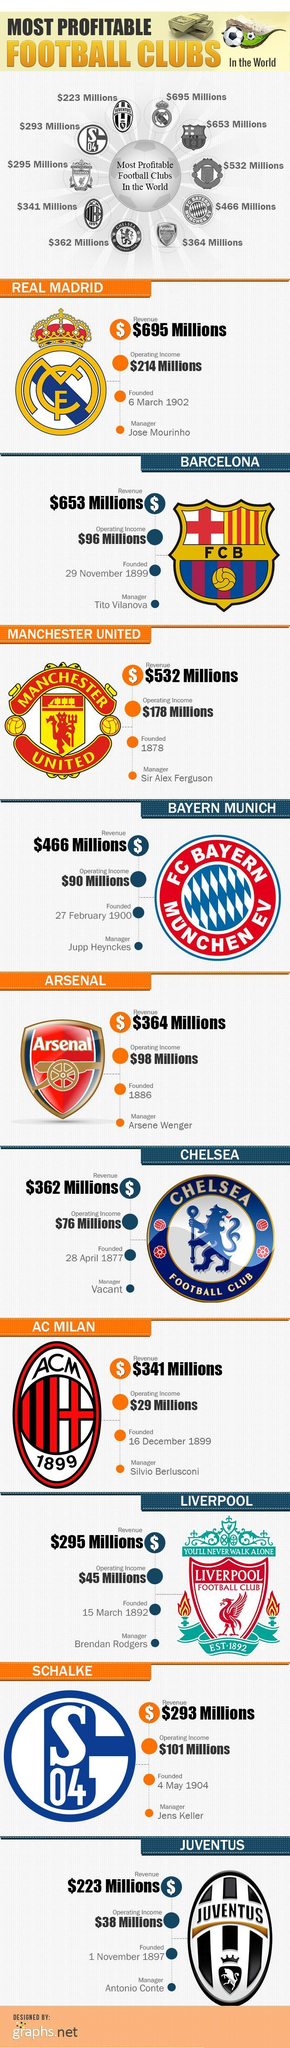which among the following club's logo has a whole sentence written on it?
Answer the question with a short phrase. liverpool which football club has the least operating income? AC Milan which football club logo has a cross sign in their crown? real madrid which football club's logo is in oval shape other than the logo of AC Milan? juventus how many stacks of currency is shown in the infographic, three or four? four which football club among the following is the first founded one? chelesa which football club is the third least profitable club in the world? liverpool which football club has the second highest operating income? manchester united which football club has the highest operating income? real madrid which football club is the latest founded among the following? schalke which football club's logo has only one alphabet and two numers? schalke how many pictures of football is/are shown in the infographic, one or three? three what is the color of the diamond shape other than blue in the logo of bayern munich, red or white?? white 